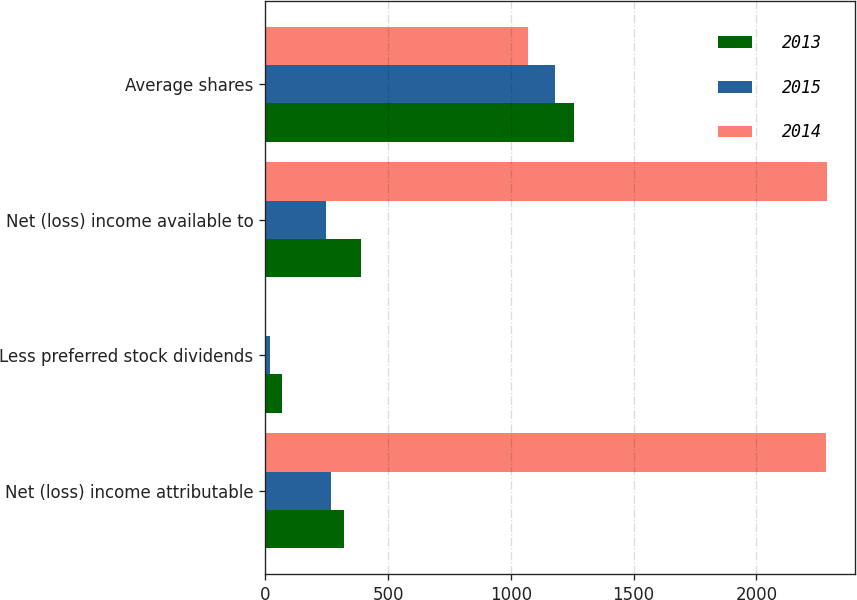Convert chart. <chart><loc_0><loc_0><loc_500><loc_500><stacked_bar_chart><ecel><fcel>Net (loss) income attributable<fcel>Less preferred stock dividends<fcel>Net (loss) income available to<fcel>Average shares<nl><fcel>2013<fcel>322<fcel>69<fcel>391<fcel>1259<nl><fcel>2015<fcel>268<fcel>21<fcel>247<fcel>1180<nl><fcel>2014<fcel>2285<fcel>2<fcel>2287<fcel>1070<nl></chart> 